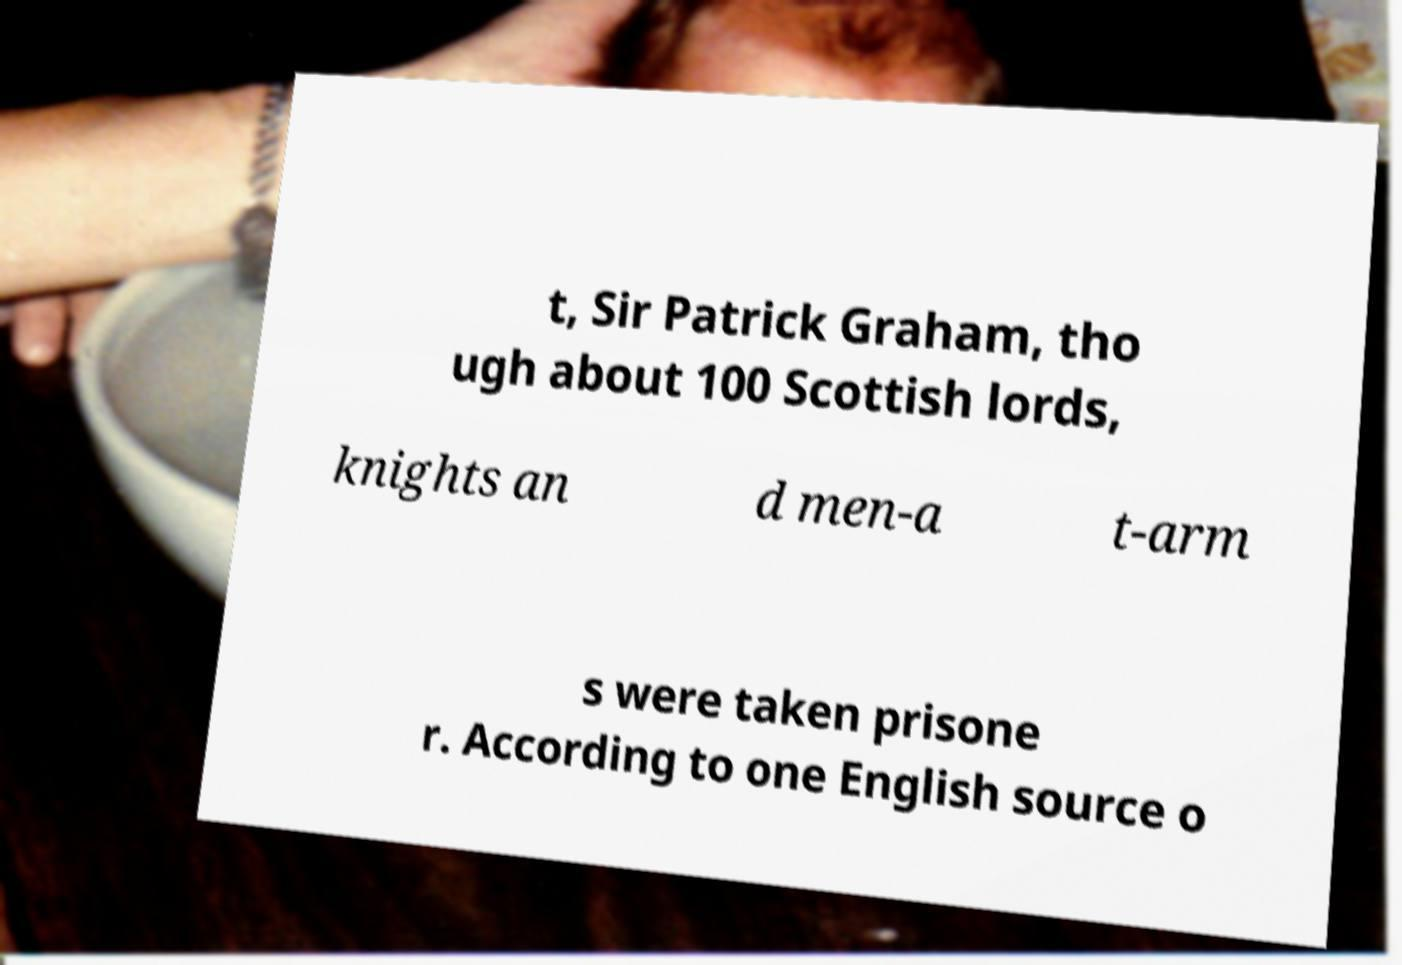Can you accurately transcribe the text from the provided image for me? t, Sir Patrick Graham, tho ugh about 100 Scottish lords, knights an d men-a t-arm s were taken prisone r. According to one English source o 